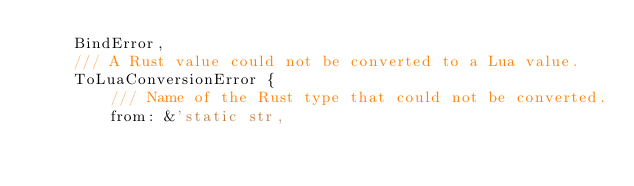<code> <loc_0><loc_0><loc_500><loc_500><_Rust_>    BindError,
    /// A Rust value could not be converted to a Lua value.
    ToLuaConversionError {
        /// Name of the Rust type that could not be converted.
        from: &'static str,</code> 